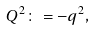Convert formula to latex. <formula><loc_0><loc_0><loc_500><loc_500>Q ^ { 2 } \colon = - q ^ { 2 } ,</formula> 